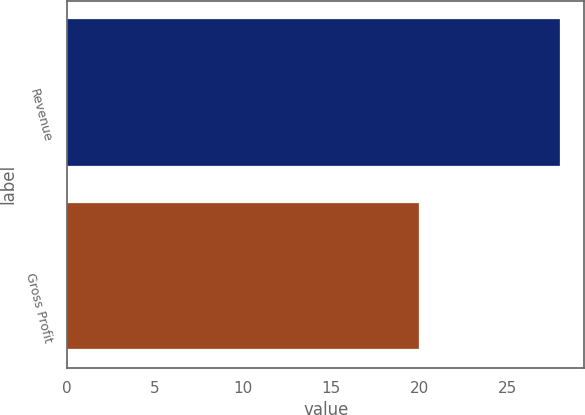<chart> <loc_0><loc_0><loc_500><loc_500><bar_chart><fcel>Revenue<fcel>Gross Profit<nl><fcel>28<fcel>20<nl></chart> 